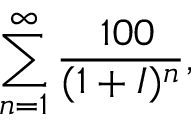Convert formula to latex. <formula><loc_0><loc_0><loc_500><loc_500>\sum _ { n = 1 } ^ { \infty } { \frac { \ 1 0 0 } { ( 1 + I ) ^ { n } } } ,</formula> 